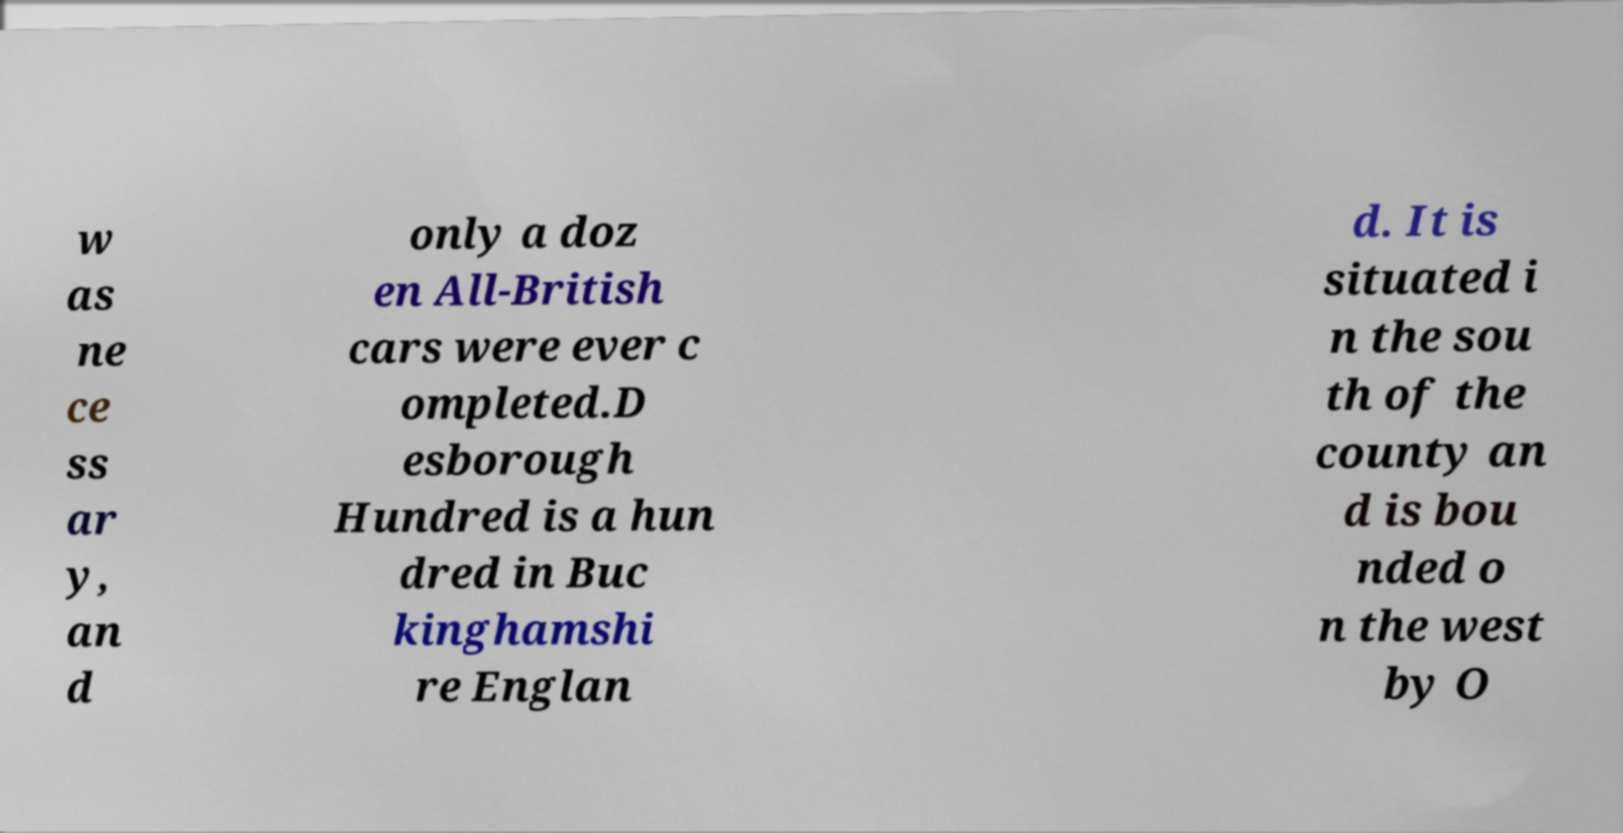Could you assist in decoding the text presented in this image and type it out clearly? w as ne ce ss ar y, an d only a doz en All-British cars were ever c ompleted.D esborough Hundred is a hun dred in Buc kinghamshi re Englan d. It is situated i n the sou th of the county an d is bou nded o n the west by O 